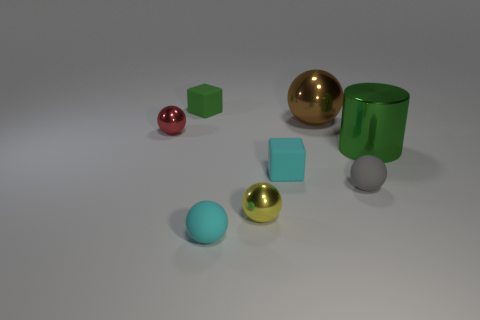What size is the metal object on the left side of the small matte cube behind the large shiny cylinder that is on the right side of the tiny red sphere?
Ensure brevity in your answer.  Small. What color is the large shiny cylinder?
Your response must be concise. Green. Is the number of tiny cyan matte things that are on the left side of the tiny cyan matte block greater than the number of cyan metallic balls?
Provide a succinct answer. Yes. There is a tiny yellow shiny ball; what number of cyan matte things are in front of it?
Ensure brevity in your answer.  1. There is a tiny matte object that is the same color as the metal cylinder; what shape is it?
Provide a succinct answer. Cube. Is there a block to the left of the rubber cube that is right of the small cyan object that is to the left of the cyan block?
Give a very brief answer. Yes. Do the gray thing and the metal cylinder have the same size?
Give a very brief answer. No. Are there an equal number of cubes behind the red ball and gray rubber things behind the tiny gray matte thing?
Your answer should be compact. No. What is the shape of the cyan rubber object to the right of the tiny yellow thing?
Offer a very short reply. Cube. There is a gray object that is the same size as the yellow thing; what is its shape?
Ensure brevity in your answer.  Sphere. 